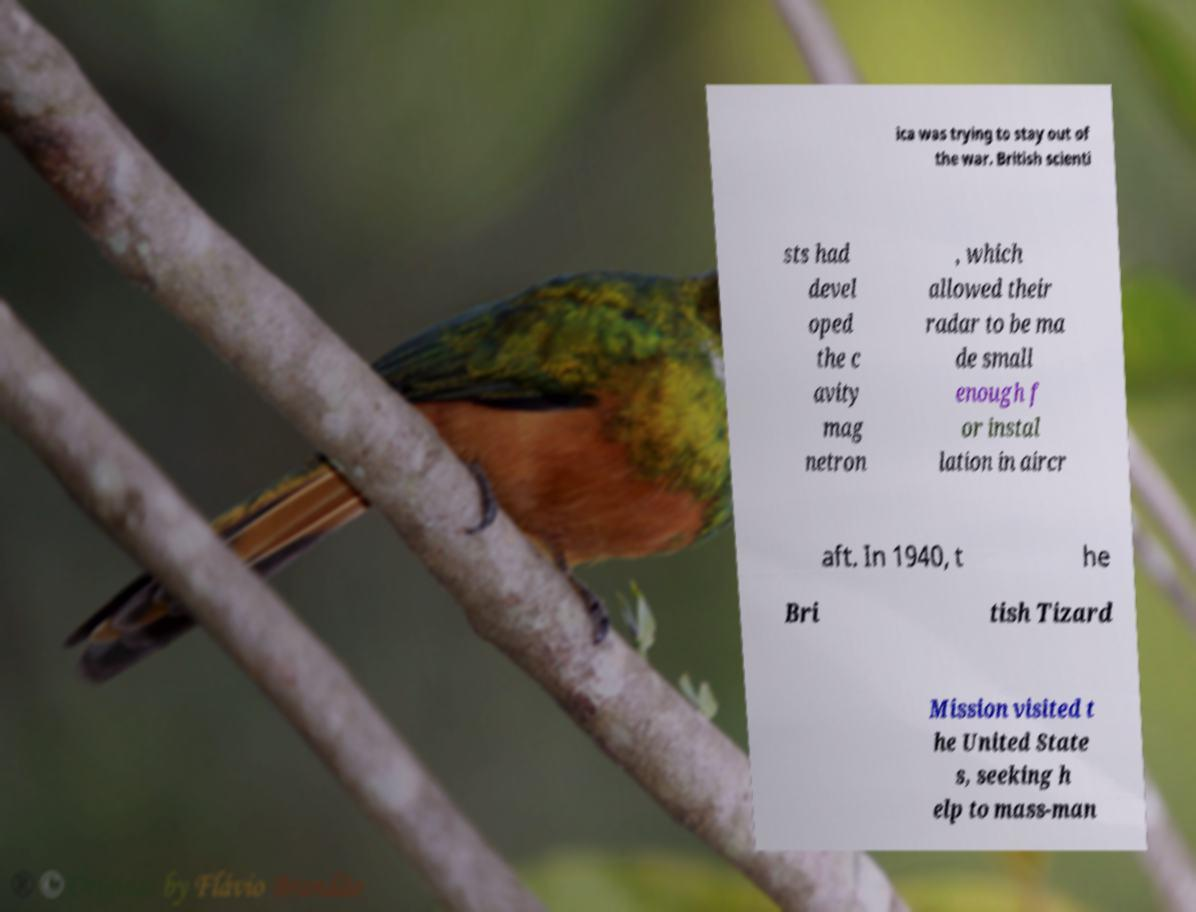Could you assist in decoding the text presented in this image and type it out clearly? ica was trying to stay out of the war. British scienti sts had devel oped the c avity mag netron , which allowed their radar to be ma de small enough f or instal lation in aircr aft. In 1940, t he Bri tish Tizard Mission visited t he United State s, seeking h elp to mass-man 